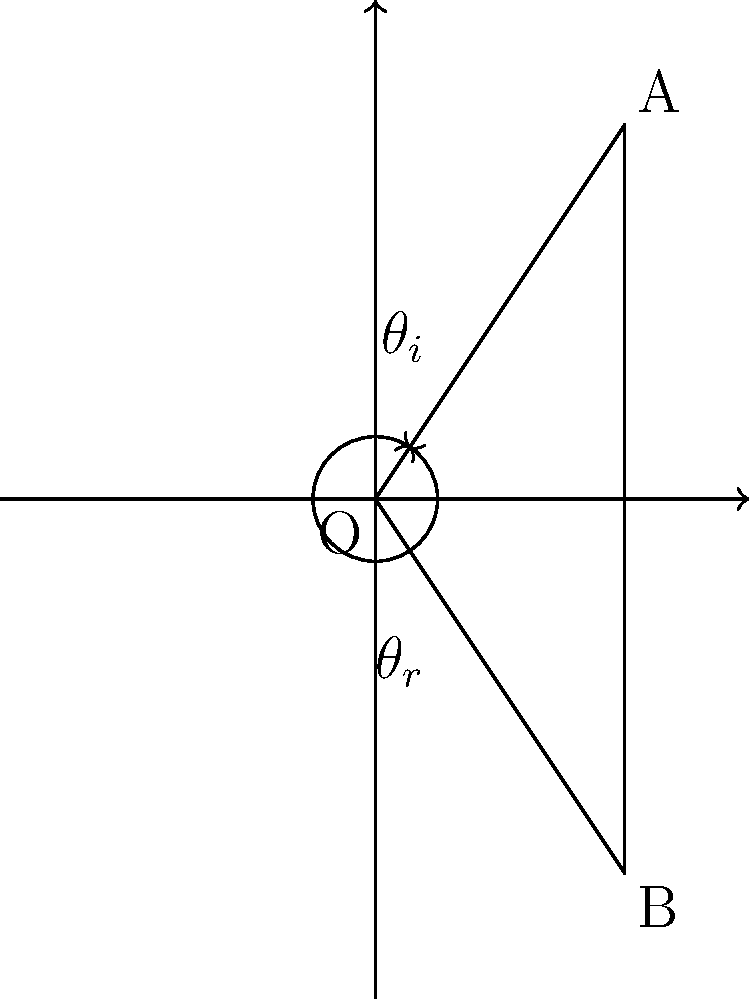In a crime scene investigation, you're examining a mirror that may have played a crucial role in a domestic dispute. To understand the visual perspectives involved, you need to analyze the reflection properties. In the diagram, if the angle of incidence ($\theta_i$) is 30°, what is the angle of reflection ($\theta_r$)? To solve this problem, we need to understand and apply the law of reflection:

1. The law of reflection states that the angle of incidence is equal to the angle of reflection.

2. In mathematical terms: $\theta_i = \theta_r$

3. We are given that the angle of incidence ($\theta_i$) is 30°.

4. Therefore, applying the law of reflection:
   $\theta_r = \theta_i = 30°$

5. This principle is crucial in understanding how light behaves when it reflects off surfaces, which can be important in reconstructing events or analyzing visual evidence in crime scenes.
Answer: $30°$ 